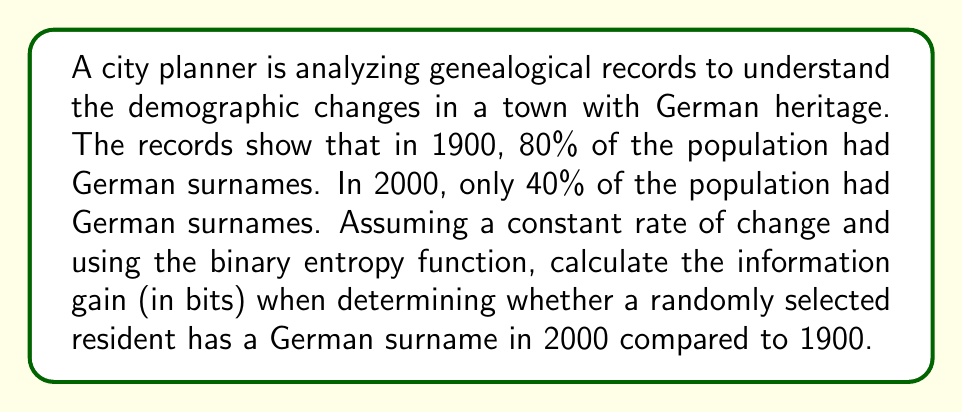What is the answer to this math problem? To solve this problem, we need to use the binary entropy function and compare the entropy values for 1900 and 2000. The binary entropy function is defined as:

$$H(p) = -p \log_2(p) - (1-p) \log_2(1-p)$$

Where $p$ is the probability of an event occurring.

Step 1: Calculate the entropy for 1900
Let $p_{1900} = 0.8$ (80% had German surnames)

$$H(p_{1900}) = -0.8 \log_2(0.8) - (1-0.8) \log_2(1-0.8)$$
$$= -0.8 \log_2(0.8) - 0.2 \log_2(0.2)$$
$$\approx 0.7219$$

Step 2: Calculate the entropy for 2000
Let $p_{2000} = 0.4$ (40% had German surnames)

$$H(p_{2000}) = -0.4 \log_2(0.4) - (1-0.4) \log_2(1-0.4)$$
$$= -0.4 \log_2(0.4) - 0.6 \log_2(0.6)$$
$$\approx 0.9710$$

Step 3: Calculate the information gain
The information gain is the difference between the entropy values:

$$\text{Information Gain} = H(p_{2000}) - H(p_{1900})$$
$$= 0.9710 - 0.7219$$
$$\approx 0.2491$$

This means that determining whether a randomly selected resident has a German surname in 2000 provides approximately 0.2491 bits more information than in 1900.
Answer: The information gain is approximately 0.2491 bits. 